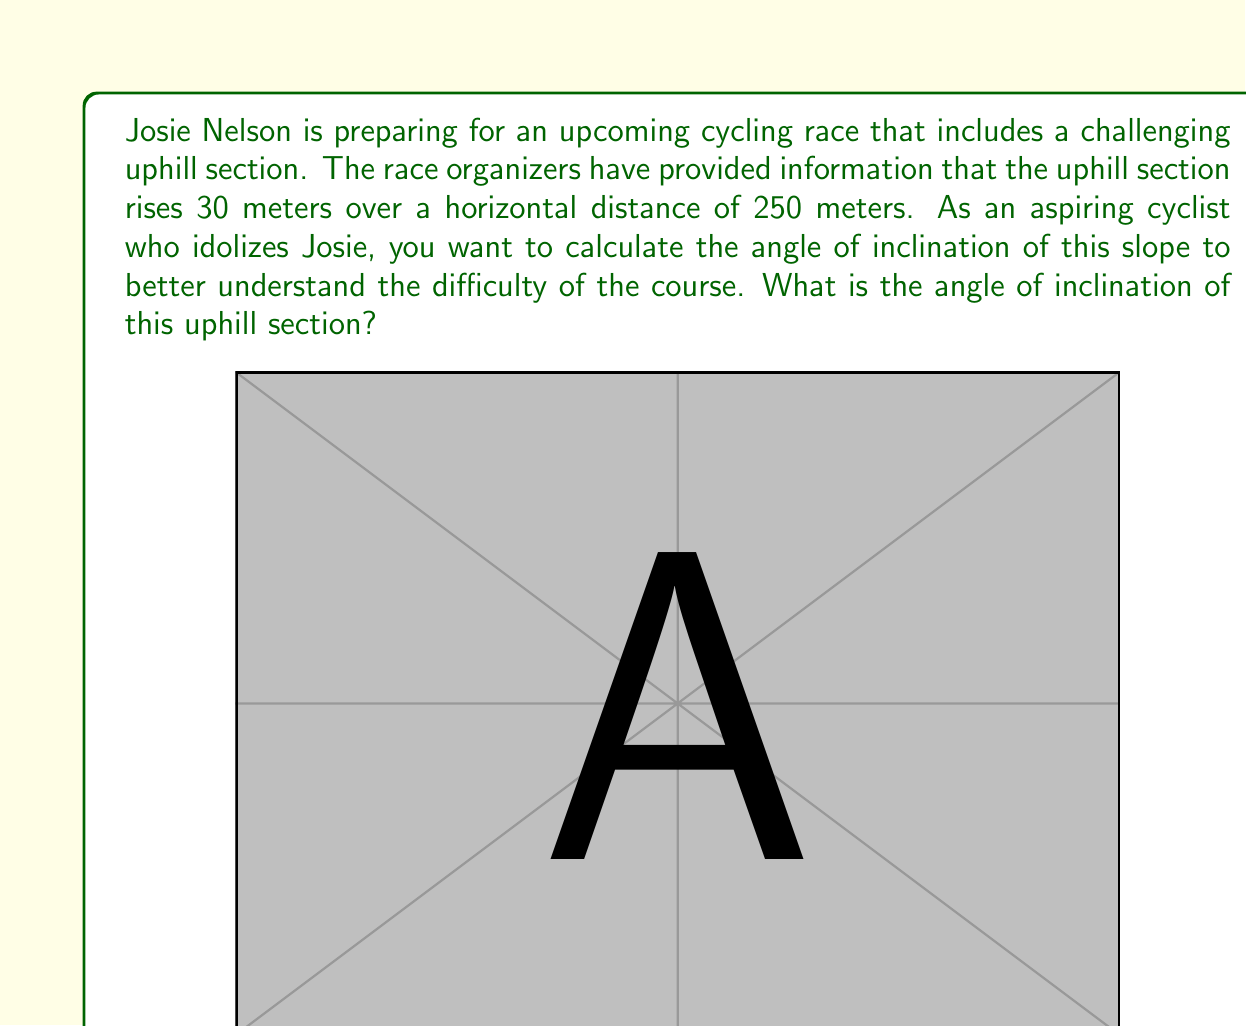Could you help me with this problem? To find the angle of inclination, we need to use trigonometry. Let's approach this step-by-step:

1) In this problem, we have a right-angled triangle where:
   - The adjacent side (horizontal distance) is 250 meters
   - The opposite side (vertical rise) is 30 meters
   - The angle of inclination is what we're trying to find

2) The trigonometric ratio that relates the opposite side and adjacent side is tangent (tan):

   $$\tan \theta = \frac{\text{opposite}}{\text{adjacent}}$$

3) Let's substitute our values:

   $$\tan \theta = \frac{30}{250}$$

4) To find $\theta$, we need to use the inverse tangent (arctan or $\tan^{-1}$):

   $$\theta = \tan^{-1}\left(\frac{30}{250}\right)$$

5) Using a calculator or computer:

   $$\theta = \tan^{-1}(0.12) \approx 6.84^\circ$$

Therefore, the angle of inclination of the uphill section is approximately 6.84°.

Note: This relatively small angle demonstrates that even a seemingly modest incline can present a significant challenge in cycling, especially over longer distances.
Answer: $6.84^\circ$ (rounded to two decimal places) 